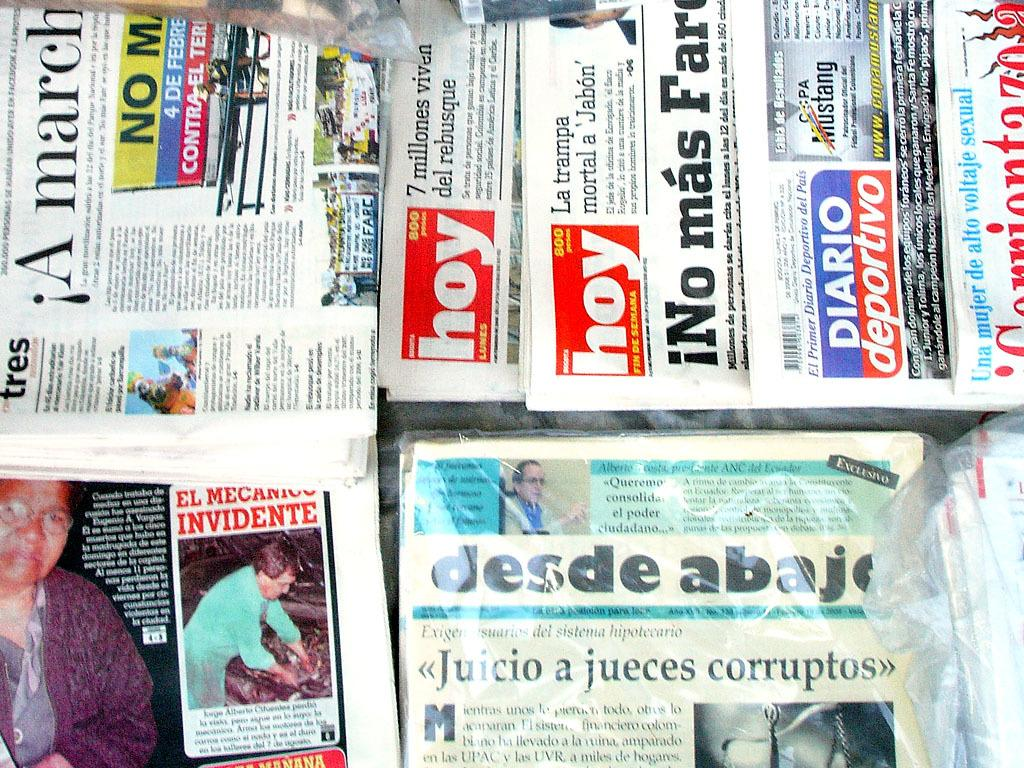<image>
Provide a brief description of the given image. A collection of newspapers with one titled Desde Abajo. 